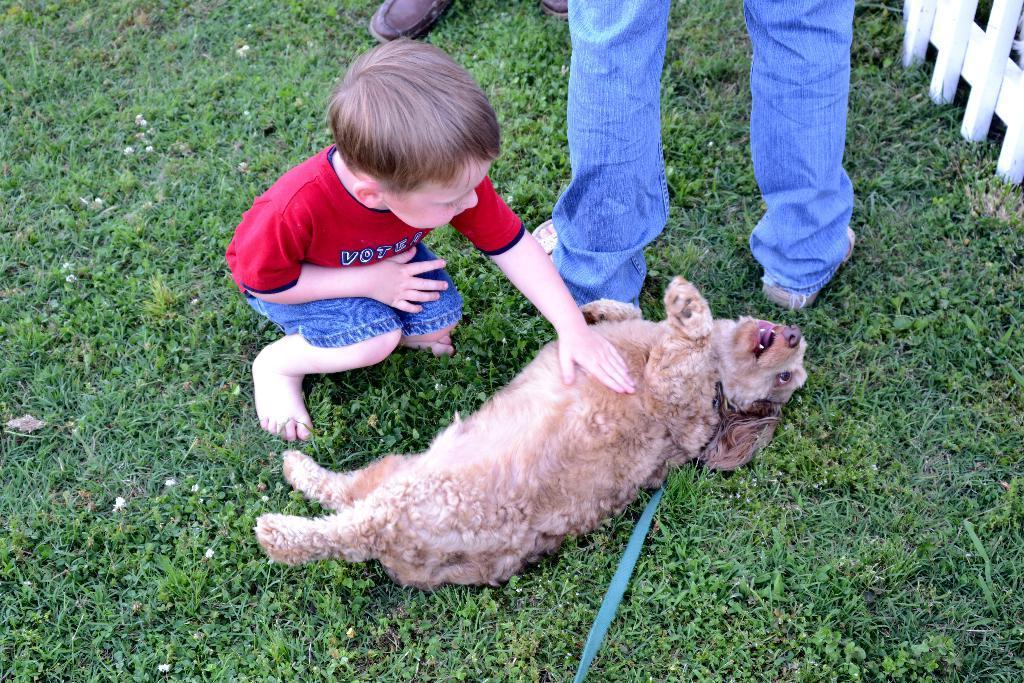Can you describe this image briefly? In this picture we can see a boy who is in red color t shirt. This is grass. And there is a dog. Here we can see legs of a person. 